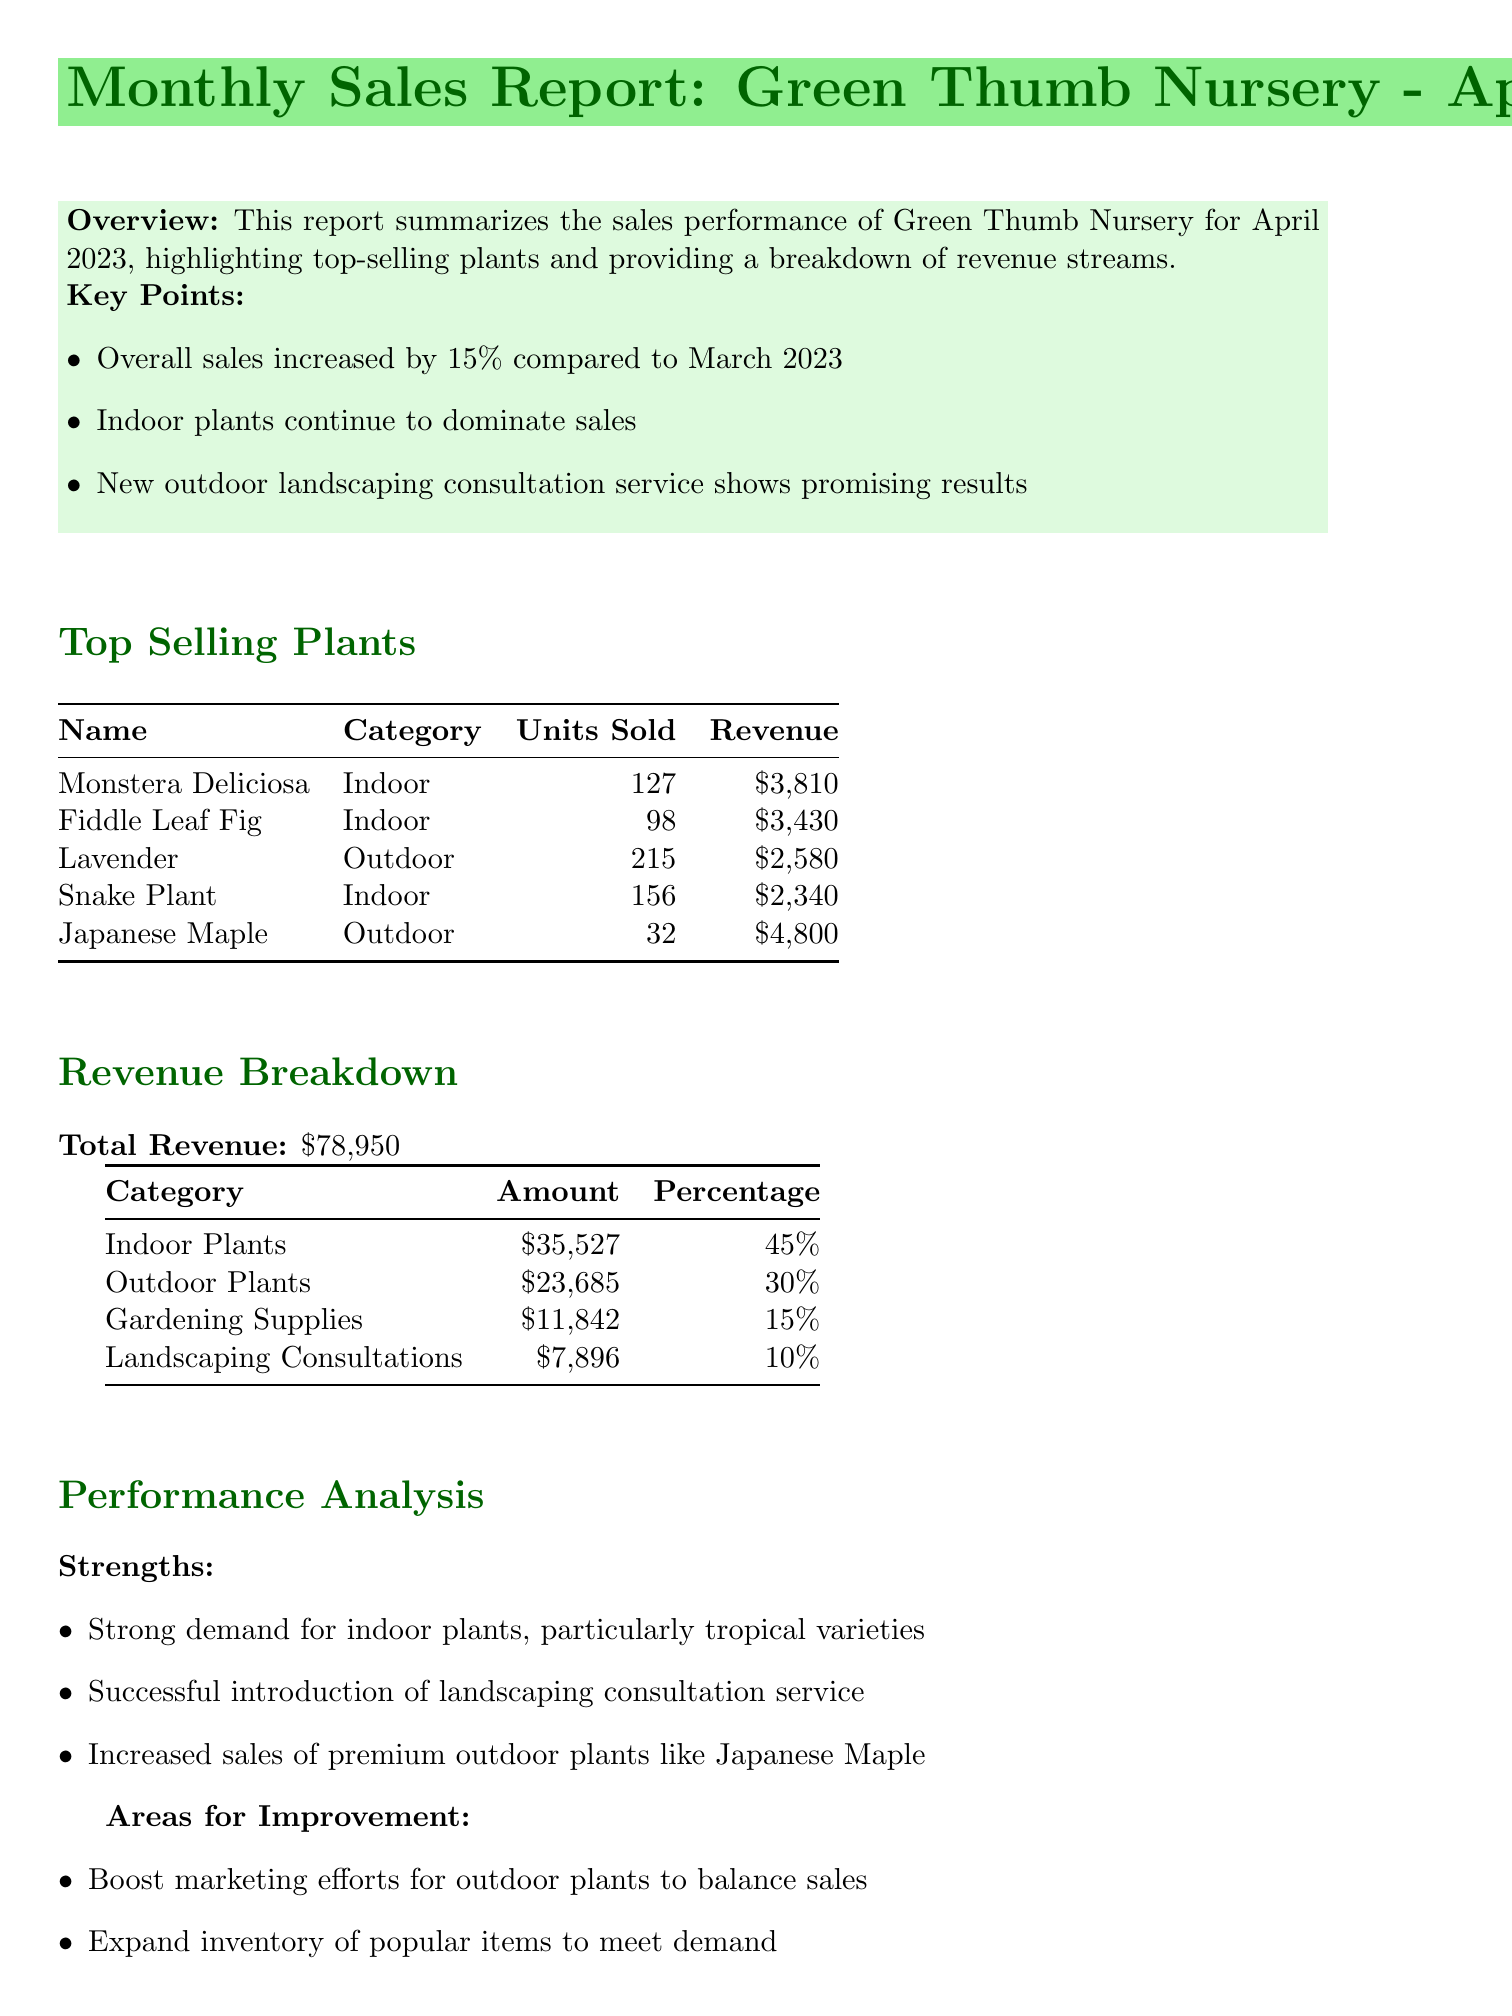What is the total revenue? The total revenue is provided in the revenue breakdown section of the document as $78,950.
Answer: $78,950 How many units of Fiddle Leaf Fig were sold? The number of units sold for Fiddle Leaf Fig is stated in the top-selling plants section, which is 98.
Answer: 98 What percentage of revenue came from indoor plants? The percentage of revenue from indoor plants is listed in the revenue breakdown section, which states 45%.
Answer: 45% What are the strengths identified in the performance analysis? The strengths section outlines three specific points regarding plant demand and service introductions, including strong demand for indoor plants.
Answer: Strong demand for indoor plants Which outdoor plant sold the most units? The top selling outdoor plant by units sold is Lavender, with 215 units sold.
Answer: Lavender What recommendations are made for promoting outdoor plants? The recommendations provide specific ideas for promoting outdoor plants, particularly through targeted email campaigns and social media promotions.
Answer: Targeted email campaigns and social media How much revenue did Gardening Supplies generate? The revenue generated from Gardening Supplies is noted in the revenue breakdown section, which shows $11,842.
Answer: $11,842 What was the increase in overall sales compared to March 2023? The document states that overall sales increased by 15% compared to the previous month.
Answer: 15% 